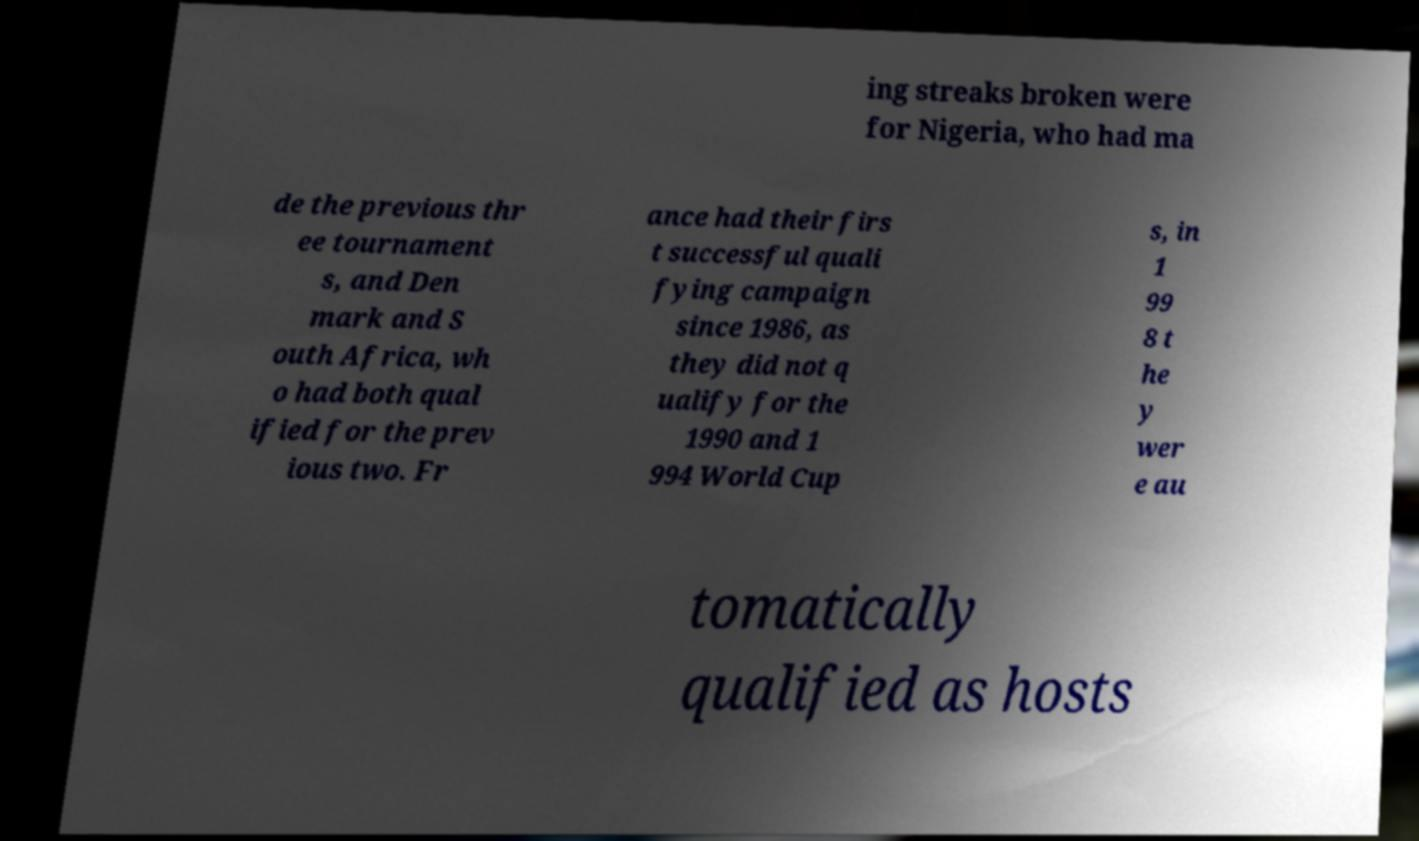Could you assist in decoding the text presented in this image and type it out clearly? ing streaks broken were for Nigeria, who had ma de the previous thr ee tournament s, and Den mark and S outh Africa, wh o had both qual ified for the prev ious two. Fr ance had their firs t successful quali fying campaign since 1986, as they did not q ualify for the 1990 and 1 994 World Cup s, in 1 99 8 t he y wer e au tomatically qualified as hosts 